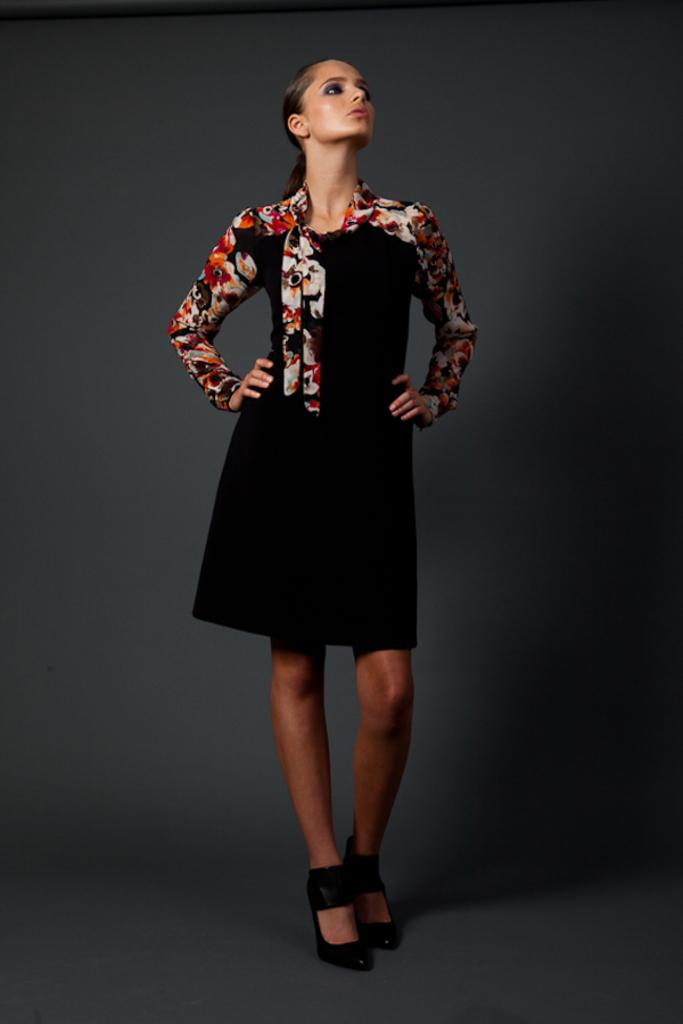Who is the main subject in the picture? There is a woman in the picture. What is the woman wearing? The woman is wearing a black and multicolor dress. What is the woman doing in the picture? The woman is standing and posing for a photograph. What type of crown is the woman wearing in the image? There is no crown present in the image; the woman is wearing a black and multicolor dress. 